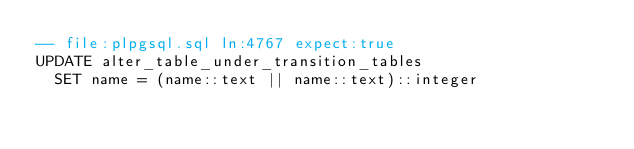<code> <loc_0><loc_0><loc_500><loc_500><_SQL_>-- file:plpgsql.sql ln:4767 expect:true
UPDATE alter_table_under_transition_tables
  SET name = (name::text || name::text)::integer
</code> 